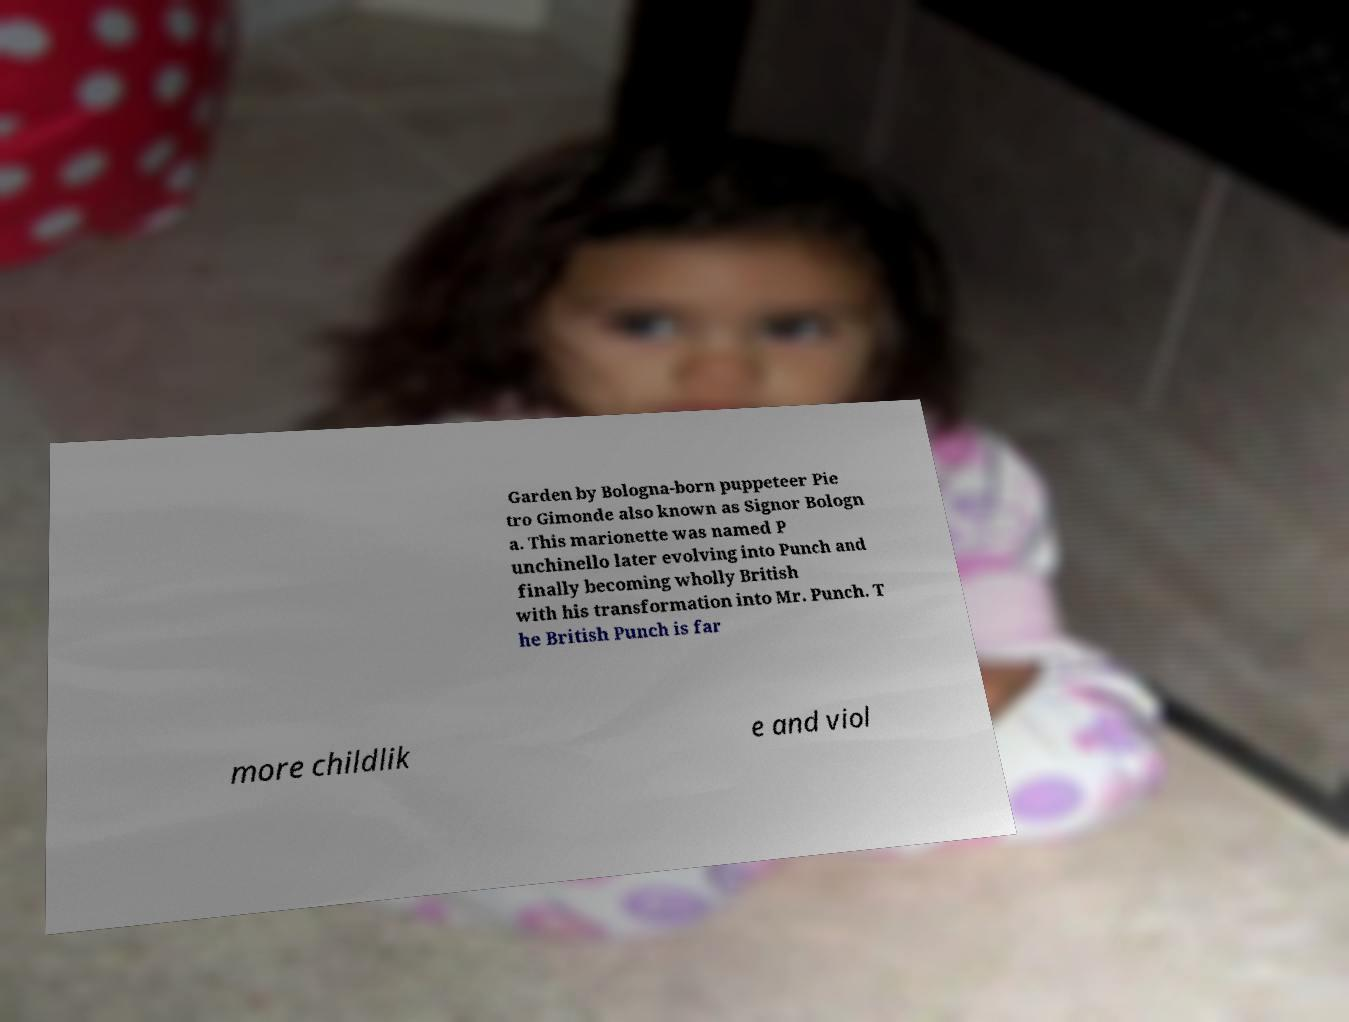Could you assist in decoding the text presented in this image and type it out clearly? Garden by Bologna-born puppeteer Pie tro Gimonde also known as Signor Bologn a. This marionette was named P unchinello later evolving into Punch and finally becoming wholly British with his transformation into Mr. Punch. T he British Punch is far more childlik e and viol 